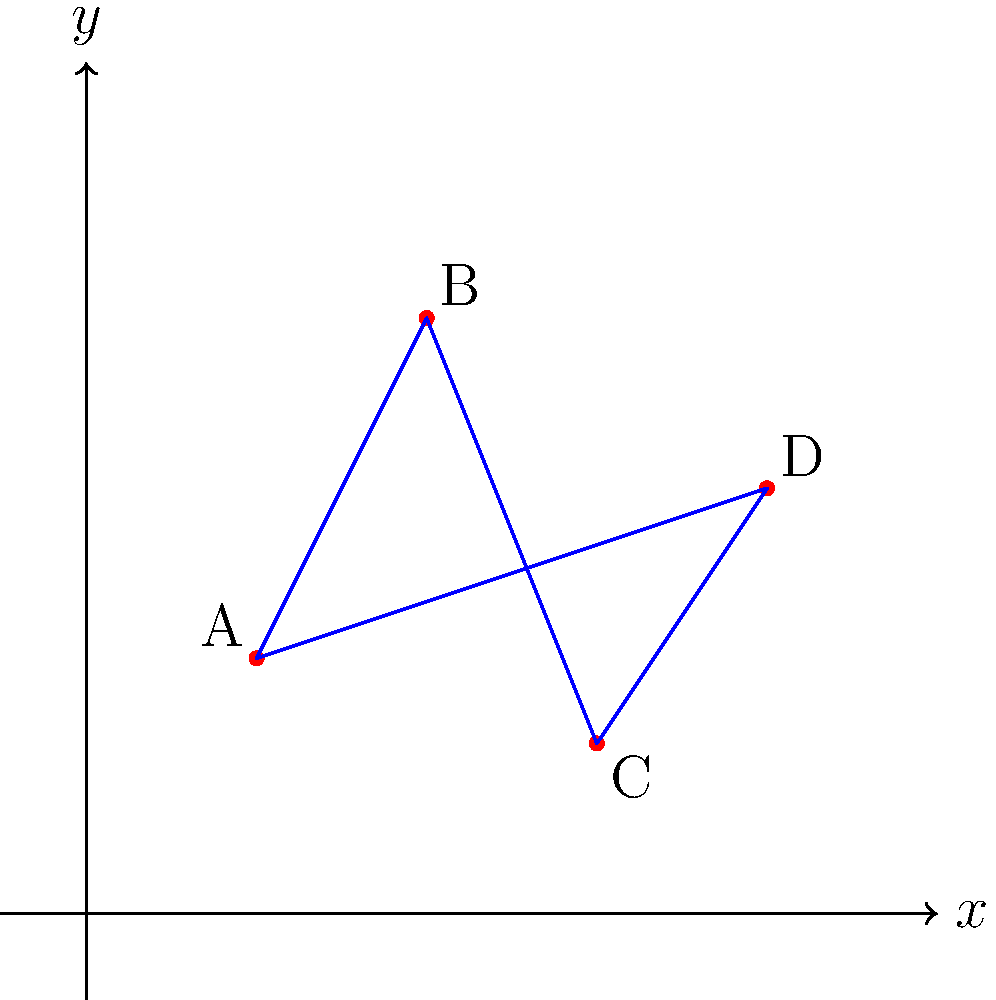For your tropical destination wedding, you want to arrange four VIP tables (A, B, C, and D) in a quadrilateral shape on the beach. The coordinates of these tables on the seating plan are A(2,3), B(4,7), C(6,2), and D(8,5). To ensure an optimal view for all guests, you want to maximize the area of this quadrilateral. What is the area of the quadrilateral ABCD in square units? To find the area of the quadrilateral ABCD, we can use the Shoelace formula (also known as the surveyor's formula). This method calculates the area of a polygon given the coordinates of its vertices.

The formula for a quadrilateral with vertices $(x_1,y_1)$, $(x_2,y_2)$, $(x_3,y_3)$, and $(x_4,y_4)$ is:

$$\text{Area} = \frac{1}{2}|(x_1y_2 + x_2y_3 + x_3y_4 + x_4y_1) - (y_1x_2 + y_2x_3 + y_3x_4 + y_4x_1)|$$

Let's substitute the given coordinates:
A(2,3), B(4,7), C(6,2), D(8,5)

$$\begin{align*}
\text{Area} &= \frac{1}{2}|(2 \cdot 7 + 4 \cdot 2 + 6 \cdot 5 + 8 \cdot 3) - (3 \cdot 4 + 7 \cdot 6 + 2 \cdot 8 + 5 \cdot 2)|\\
&= \frac{1}{2}|(14 + 8 + 30 + 24) - (12 + 42 + 16 + 10)|\\
&= \frac{1}{2}|76 - 80|\\
&= \frac{1}{2} \cdot 4\\
&= 2
\end{align*}$$

Therefore, the area of the quadrilateral ABCD is 2 square units.
Answer: 2 square units 